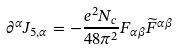Convert formula to latex. <formula><loc_0><loc_0><loc_500><loc_500>\partial ^ { \alpha } J _ { 5 , \alpha } = - \frac { e ^ { 2 } N _ { c } } { 4 8 \pi ^ { 2 } } F _ { \alpha \beta } \widetilde { F } ^ { \alpha \beta }</formula> 